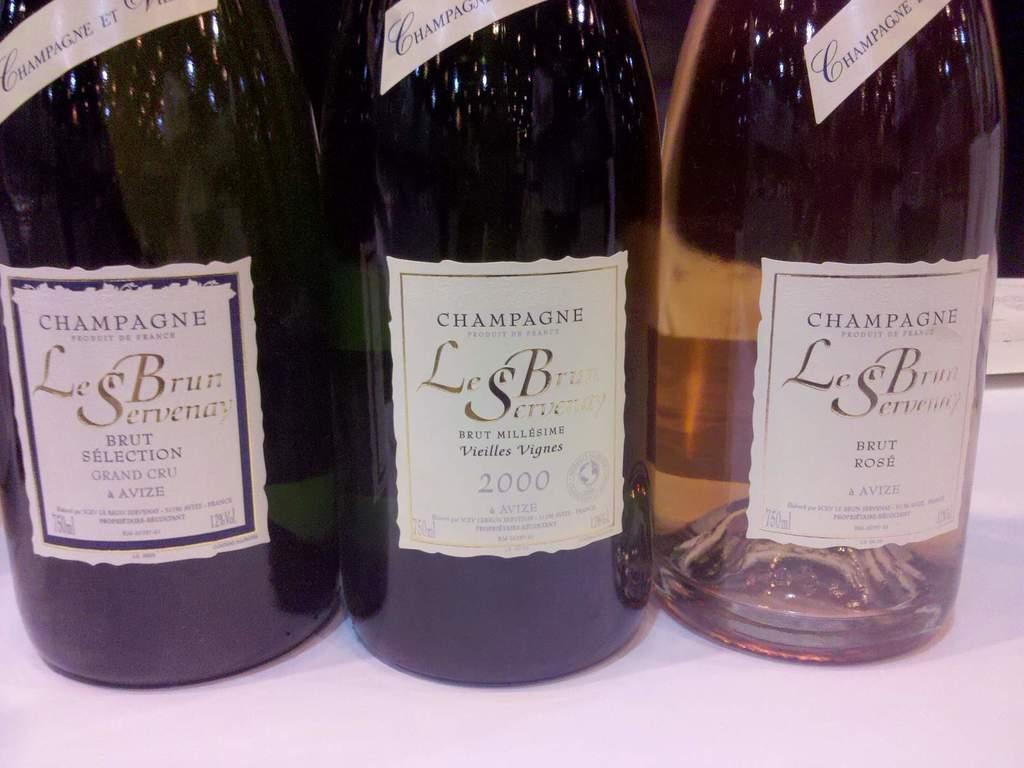What objects can be seen in the image? There are bottles in the image. Where is the zipper located on the bottles in the image? There is no zipper present on the bottles in the image. What type of crib is visible in the image? There is no crib present in the image. 